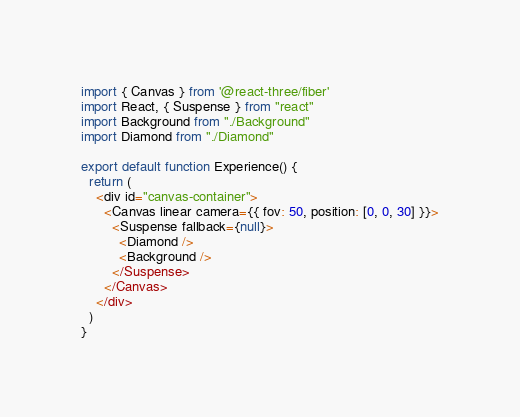<code> <loc_0><loc_0><loc_500><loc_500><_JavaScript_>import { Canvas } from '@react-three/fiber'
import React, { Suspense } from "react"
import Background from "./Background"
import Diamond from "./Diamond"

export default function Experience() {
  return (
    <div id="canvas-container">
      <Canvas linear camera={{ fov: 50, position: [0, 0, 30] }}>
        <Suspense fallback={null}>
          <Diamond />
          <Background />
        </Suspense>
      </Canvas>
    </div>
  )
}
</code> 